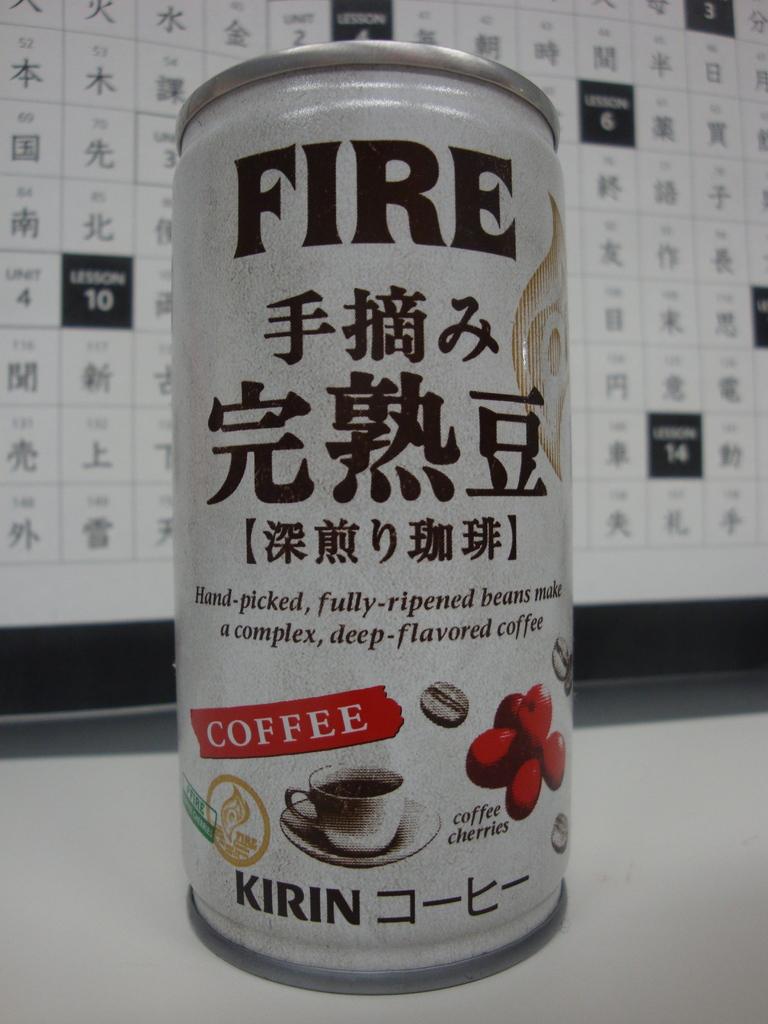What is the beverage called?
Provide a short and direct response. Fire. 